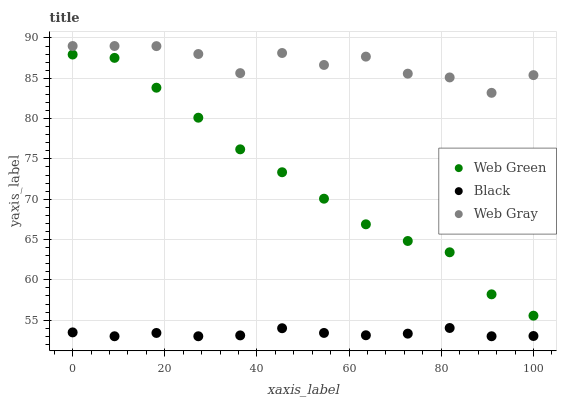Does Black have the minimum area under the curve?
Answer yes or no. Yes. Does Web Gray have the maximum area under the curve?
Answer yes or no. Yes. Does Web Green have the minimum area under the curve?
Answer yes or no. No. Does Web Green have the maximum area under the curve?
Answer yes or no. No. Is Black the smoothest?
Answer yes or no. Yes. Is Web Gray the roughest?
Answer yes or no. Yes. Is Web Green the smoothest?
Answer yes or no. No. Is Web Green the roughest?
Answer yes or no. No. Does Black have the lowest value?
Answer yes or no. Yes. Does Web Green have the lowest value?
Answer yes or no. No. Does Web Gray have the highest value?
Answer yes or no. Yes. Does Web Green have the highest value?
Answer yes or no. No. Is Black less than Web Gray?
Answer yes or no. Yes. Is Web Gray greater than Web Green?
Answer yes or no. Yes. Does Black intersect Web Gray?
Answer yes or no. No. 